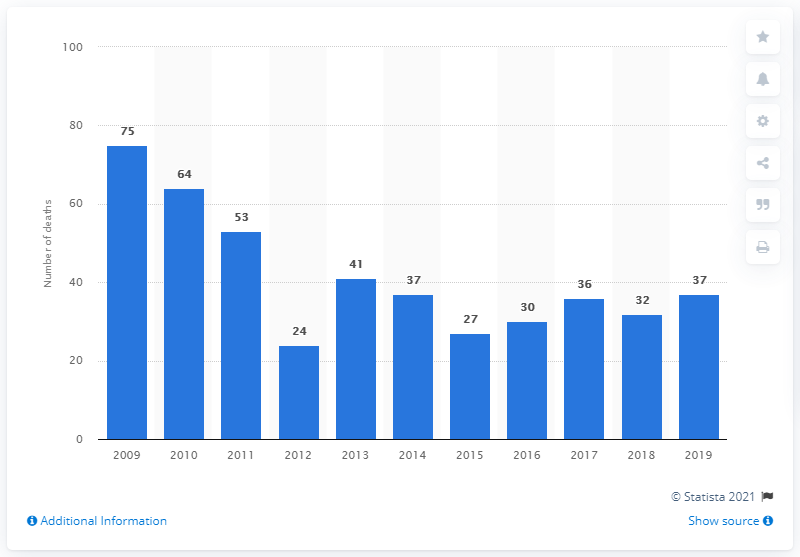Outline some significant characteristics in this image. There were 37 alcohol-related deaths in Denmark in 2019. In 2019, there were 75 alcohol-related deaths in Denmark. 